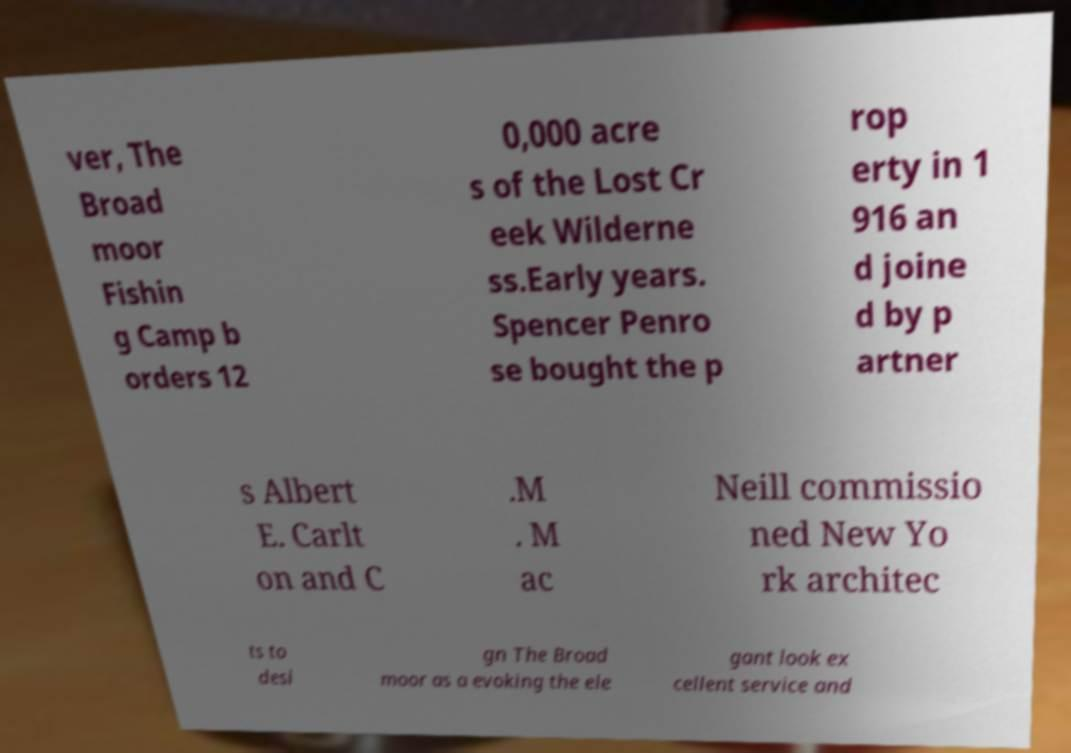Please read and relay the text visible in this image. What does it say? ver, The Broad moor Fishin g Camp b orders 12 0,000 acre s of the Lost Cr eek Wilderne ss.Early years. Spencer Penro se bought the p rop erty in 1 916 an d joine d by p artner s Albert E. Carlt on and C .M . M ac Neill commissio ned New Yo rk architec ts to desi gn The Broad moor as a evoking the ele gant look ex cellent service and 